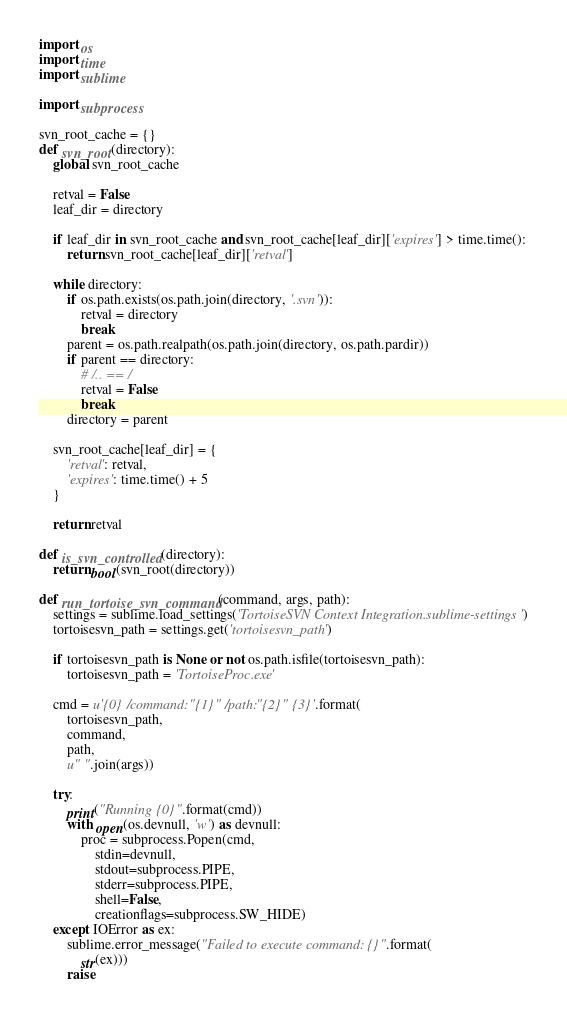<code> <loc_0><loc_0><loc_500><loc_500><_Python_>import os
import time
import sublime

import subprocess

svn_root_cache = {}
def svn_root(directory):
    global svn_root_cache

    retval = False
    leaf_dir = directory

    if leaf_dir in svn_root_cache and svn_root_cache[leaf_dir]['expires'] > time.time():
        return svn_root_cache[leaf_dir]['retval']

    while directory:
        if os.path.exists(os.path.join(directory, '.svn')):
            retval = directory
            break
        parent = os.path.realpath(os.path.join(directory, os.path.pardir))
        if parent == directory:
            # /.. == /
            retval = False
            break
        directory = parent

    svn_root_cache[leaf_dir] = {
        'retval': retval,
        'expires': time.time() + 5
    }

    return retval

def is_svn_controlled(directory):
    return bool(svn_root(directory))

def run_tortoise_svn_command(command, args, path):
    settings = sublime.load_settings('TortoiseSVN Context Integration.sublime-settings')
    tortoisesvn_path = settings.get('tortoisesvn_path')

    if tortoisesvn_path is None or not os.path.isfile(tortoisesvn_path):
        tortoisesvn_path = 'TortoiseProc.exe'

    cmd = u'{0} /command:"{1}" /path:"{2}" {3}'.format(
        tortoisesvn_path,
        command,
        path,
        u" ".join(args))

    try:
        print("Running {0}".format(cmd))
        with open(os.devnull, 'w') as devnull:
            proc = subprocess.Popen(cmd,
                stdin=devnull,
                stdout=subprocess.PIPE,
                stderr=subprocess.PIPE,
                shell=False,
                creationflags=subprocess.SW_HIDE)
    except IOError as ex:
        sublime.error_message("Failed to execute command: {}".format(
            str(ex)))
        raise
</code> 